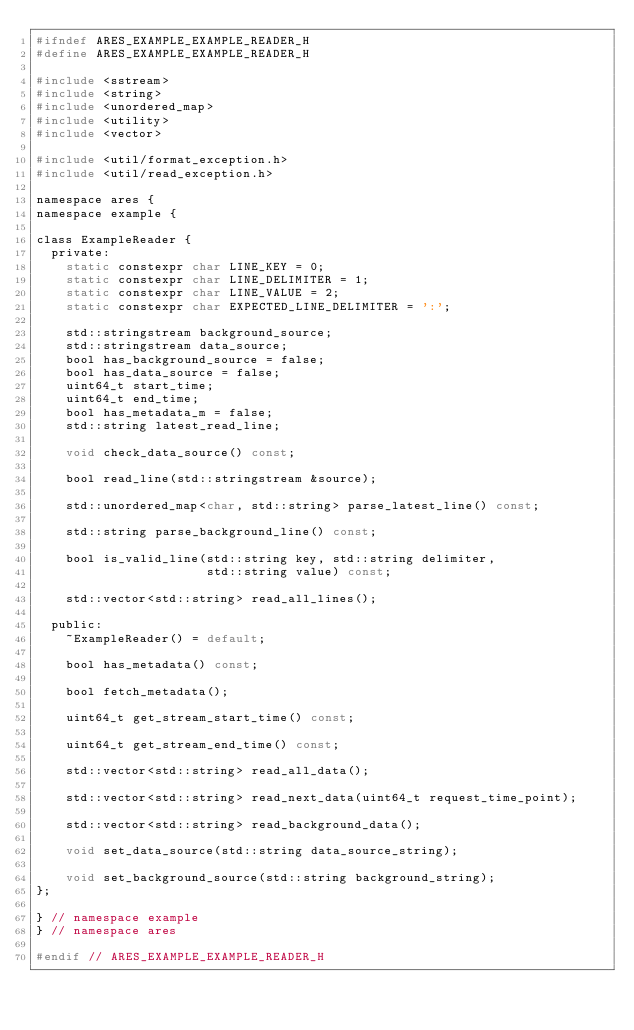Convert code to text. <code><loc_0><loc_0><loc_500><loc_500><_C_>#ifndef ARES_EXAMPLE_EXAMPLE_READER_H
#define ARES_EXAMPLE_EXAMPLE_READER_H

#include <sstream>
#include <string>
#include <unordered_map>
#include <utility>
#include <vector>

#include <util/format_exception.h>
#include <util/read_exception.h>

namespace ares {
namespace example {

class ExampleReader {
  private:
    static constexpr char LINE_KEY = 0;
    static constexpr char LINE_DELIMITER = 1;
    static constexpr char LINE_VALUE = 2;
    static constexpr char EXPECTED_LINE_DELIMITER = ':';

    std::stringstream background_source;
    std::stringstream data_source;
    bool has_background_source = false;
    bool has_data_source = false;
    uint64_t start_time;
    uint64_t end_time;
    bool has_metadata_m = false;
    std::string latest_read_line;

    void check_data_source() const;

    bool read_line(std::stringstream &source);

    std::unordered_map<char, std::string> parse_latest_line() const;

    std::string parse_background_line() const; 

    bool is_valid_line(std::string key, std::string delimiter,
                       std::string value) const;

    std::vector<std::string> read_all_lines();

  public:
    ~ExampleReader() = default;

    bool has_metadata() const;

    bool fetch_metadata();

    uint64_t get_stream_start_time() const;

    uint64_t get_stream_end_time() const;

    std::vector<std::string> read_all_data();

    std::vector<std::string> read_next_data(uint64_t request_time_point);

    std::vector<std::string> read_background_data();

    void set_data_source(std::string data_source_string);

    void set_background_source(std::string background_string);
};

} // namespace example
} // namespace ares

#endif // ARES_EXAMPLE_EXAMPLE_READER_H
</code> 